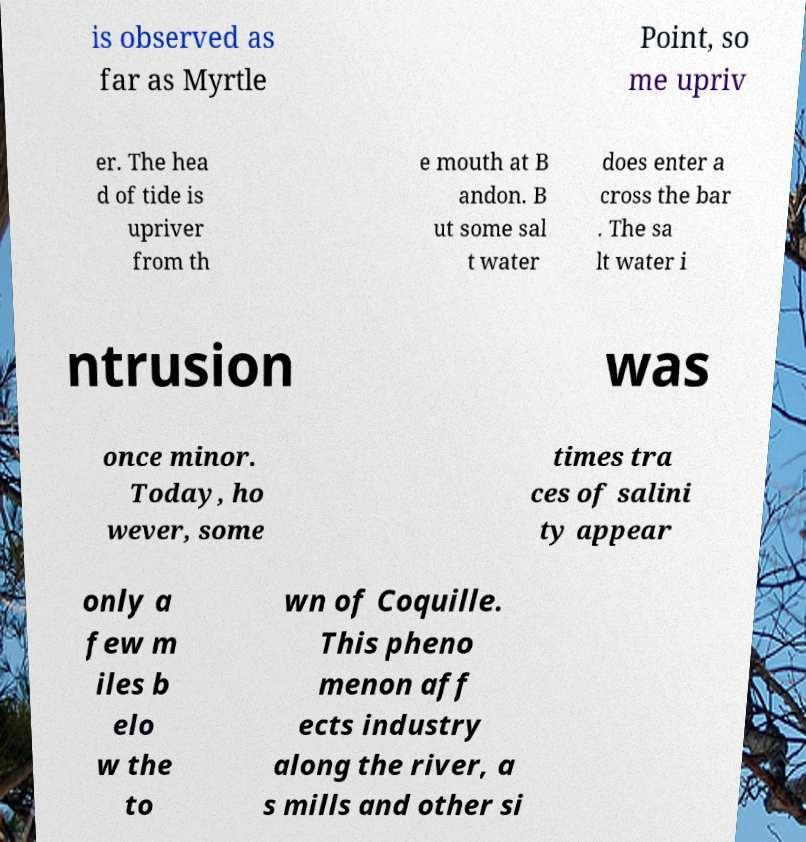Can you read and provide the text displayed in the image?This photo seems to have some interesting text. Can you extract and type it out for me? is observed as far as Myrtle Point, so me upriv er. The hea d of tide is upriver from th e mouth at B andon. B ut some sal t water does enter a cross the bar . The sa lt water i ntrusion was once minor. Today, ho wever, some times tra ces of salini ty appear only a few m iles b elo w the to wn of Coquille. This pheno menon aff ects industry along the river, a s mills and other si 